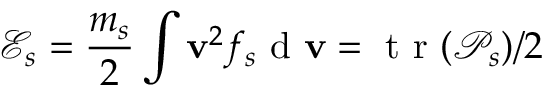Convert formula to latex. <formula><loc_0><loc_0><loc_500><loc_500>\mathcal { E } _ { s } = \frac { m _ { s } } { 2 } \int v ^ { 2 } f _ { s } d v = t r ( \mathcal { P } _ { s } ) / 2</formula> 